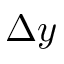<formula> <loc_0><loc_0><loc_500><loc_500>\Delta y</formula> 